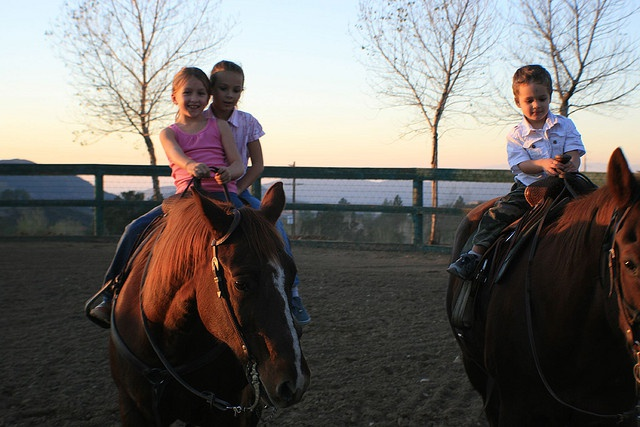Describe the objects in this image and their specific colors. I can see horse in white, black, maroon, and gray tones, horse in white, black, maroon, and brown tones, people in white, black, gray, maroon, and purple tones, people in white, black, gray, and maroon tones, and people in white, black, purple, and gray tones in this image. 